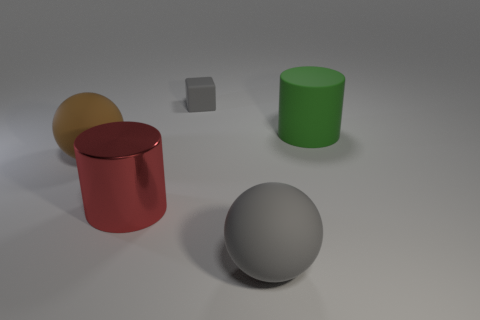Subtract all green cylinders. How many cylinders are left? 1 Add 5 tiny things. How many objects exist? 10 Subtract all cubes. How many objects are left? 4 Subtract 2 spheres. How many spheres are left? 0 Subtract all yellow cylinders. How many brown spheres are left? 1 Subtract all large blue things. Subtract all rubber objects. How many objects are left? 1 Add 2 rubber things. How many rubber things are left? 6 Add 5 tiny green rubber balls. How many tiny green rubber balls exist? 5 Subtract 0 brown cylinders. How many objects are left? 5 Subtract all red balls. Subtract all green blocks. How many balls are left? 2 